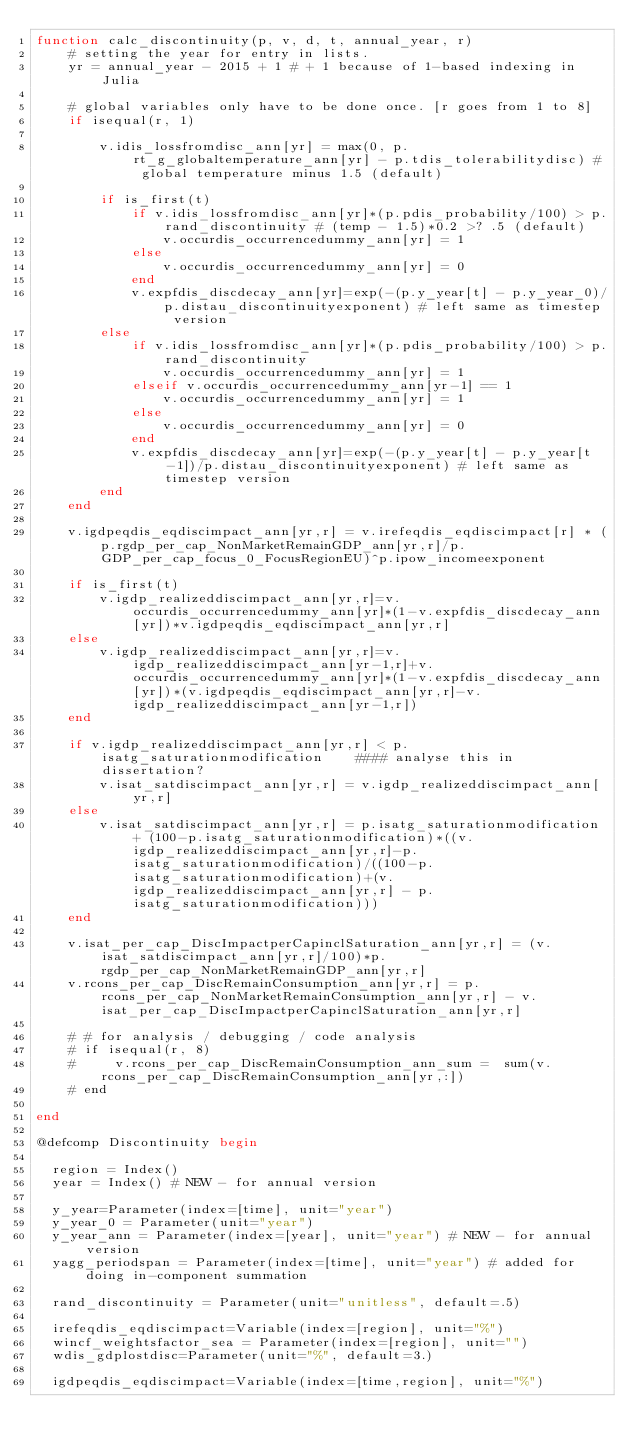Convert code to text. <code><loc_0><loc_0><loc_500><loc_500><_Julia_>function calc_discontinuity(p, v, d, t, annual_year, r)
    # setting the year for entry in lists.
    yr = annual_year - 2015 + 1 # + 1 because of 1-based indexing in Julia

    # global variables only have to be done once. [r goes from 1 to 8]
    if isequal(r, 1)

        v.idis_lossfromdisc_ann[yr] = max(0, p.rt_g_globaltemperature_ann[yr] - p.tdis_tolerabilitydisc) # global temperature minus 1.5 (default)

        if is_first(t)
            if v.idis_lossfromdisc_ann[yr]*(p.pdis_probability/100) > p.rand_discontinuity # (temp - 1.5)*0.2 >? .5 (default)
                v.occurdis_occurrencedummy_ann[yr] = 1
            else
                v.occurdis_occurrencedummy_ann[yr] = 0
            end
            v.expfdis_discdecay_ann[yr]=exp(-(p.y_year[t] - p.y_year_0)/p.distau_discontinuityexponent) # left same as timestep version
        else
            if v.idis_lossfromdisc_ann[yr]*(p.pdis_probability/100) > p.rand_discontinuity
                v.occurdis_occurrencedummy_ann[yr] = 1
            elseif v.occurdis_occurrencedummy_ann[yr-1] == 1
                v.occurdis_occurrencedummy_ann[yr] = 1
            else
                v.occurdis_occurrencedummy_ann[yr] = 0
            end
            v.expfdis_discdecay_ann[yr]=exp(-(p.y_year[t] - p.y_year[t-1])/p.distau_discontinuityexponent) # left same as timestep version
        end
    end

    v.igdpeqdis_eqdiscimpact_ann[yr,r] = v.irefeqdis_eqdiscimpact[r] * (p.rgdp_per_cap_NonMarketRemainGDP_ann[yr,r]/p.GDP_per_cap_focus_0_FocusRegionEU)^p.ipow_incomeexponent

    if is_first(t)
        v.igdp_realizeddiscimpact_ann[yr,r]=v.occurdis_occurrencedummy_ann[yr]*(1-v.expfdis_discdecay_ann[yr])*v.igdpeqdis_eqdiscimpact_ann[yr,r]
    else
        v.igdp_realizeddiscimpact_ann[yr,r]=v.igdp_realizeddiscimpact_ann[yr-1,r]+v.occurdis_occurrencedummy_ann[yr]*(1-v.expfdis_discdecay_ann[yr])*(v.igdpeqdis_eqdiscimpact_ann[yr,r]-v.igdp_realizeddiscimpact_ann[yr-1,r])
    end

    if v.igdp_realizeddiscimpact_ann[yr,r] < p.isatg_saturationmodification    #### analyse this in dissertation?
        v.isat_satdiscimpact_ann[yr,r] = v.igdp_realizeddiscimpact_ann[yr,r]
    else
        v.isat_satdiscimpact_ann[yr,r] = p.isatg_saturationmodification + (100-p.isatg_saturationmodification)*((v.igdp_realizeddiscimpact_ann[yr,r]-p.isatg_saturationmodification)/((100-p.isatg_saturationmodification)+(v.igdp_realizeddiscimpact_ann[yr,r] - p.isatg_saturationmodification)))
    end

    v.isat_per_cap_DiscImpactperCapinclSaturation_ann[yr,r] = (v.isat_satdiscimpact_ann[yr,r]/100)*p.rgdp_per_cap_NonMarketRemainGDP_ann[yr,r]
    v.rcons_per_cap_DiscRemainConsumption_ann[yr,r] = p.rcons_per_cap_NonMarketRemainConsumption_ann[yr,r] - v.isat_per_cap_DiscImpactperCapinclSaturation_ann[yr,r]

    # # for analysis / debugging / code analysis
    # if isequal(r, 8)
    #     v.rcons_per_cap_DiscRemainConsumption_ann_sum =  sum(v.rcons_per_cap_DiscRemainConsumption_ann[yr,:])
    # end

end

@defcomp Discontinuity begin

  region = Index()
  year = Index() # NEW - for annual version

  y_year=Parameter(index=[time], unit="year")
  y_year_0 = Parameter(unit="year")
  y_year_ann = Parameter(index=[year], unit="year") # NEW - for annual version
  yagg_periodspan = Parameter(index=[time], unit="year") # added for doing in-component summation

  rand_discontinuity = Parameter(unit="unitless", default=.5)

  irefeqdis_eqdiscimpact=Variable(index=[region], unit="%")
  wincf_weightsfactor_sea = Parameter(index=[region], unit="")
  wdis_gdplostdisc=Parameter(unit="%", default=3.)

  igdpeqdis_eqdiscimpact=Variable(index=[time,region], unit="%")</code> 